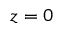<formula> <loc_0><loc_0><loc_500><loc_500>z = 0</formula> 